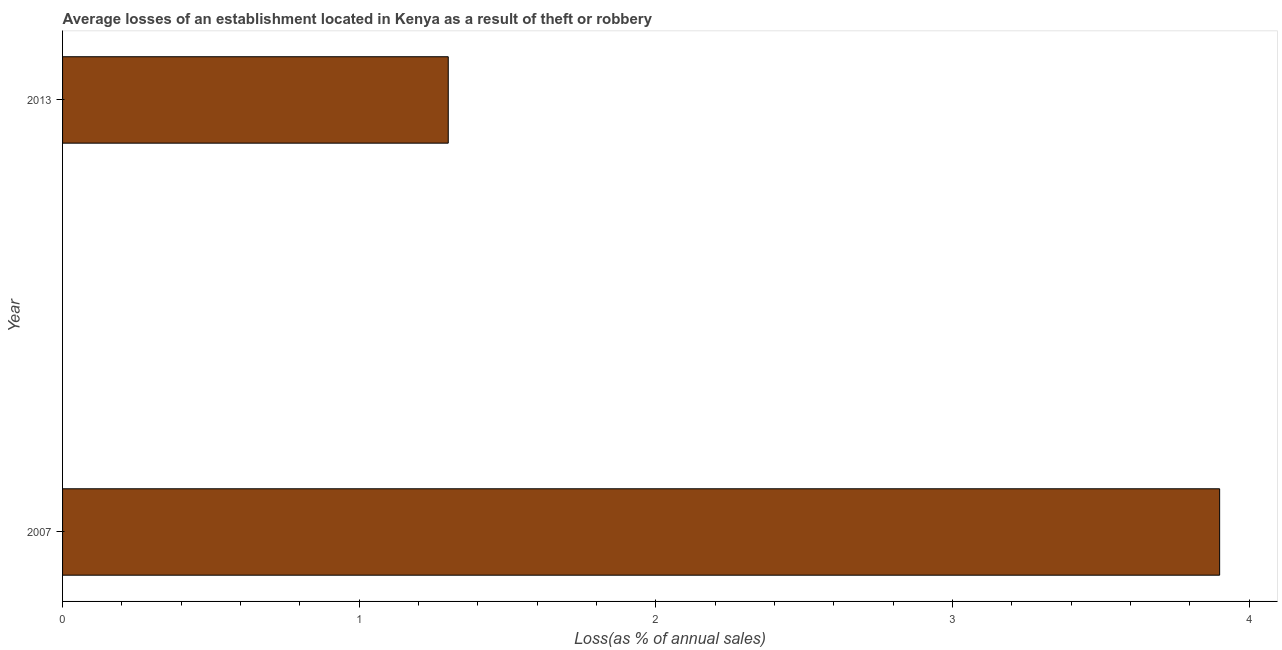Does the graph contain any zero values?
Provide a short and direct response. No. What is the title of the graph?
Make the answer very short. Average losses of an establishment located in Kenya as a result of theft or robbery. What is the label or title of the X-axis?
Offer a very short reply. Loss(as % of annual sales). What is the losses due to theft in 2013?
Your answer should be compact. 1.3. Across all years, what is the maximum losses due to theft?
Offer a terse response. 3.9. In which year was the losses due to theft minimum?
Offer a very short reply. 2013. What is the sum of the losses due to theft?
Your answer should be compact. 5.2. What is the difference between the losses due to theft in 2007 and 2013?
Offer a very short reply. 2.6. What is the average losses due to theft per year?
Give a very brief answer. 2.6. What is the median losses due to theft?
Provide a short and direct response. 2.6. In how many years, is the losses due to theft greater than 0.2 %?
Ensure brevity in your answer.  2. Do a majority of the years between 2007 and 2013 (inclusive) have losses due to theft greater than 2.2 %?
Provide a succinct answer. No. Is the losses due to theft in 2007 less than that in 2013?
Provide a succinct answer. No. Are all the bars in the graph horizontal?
Give a very brief answer. Yes. What is the difference between two consecutive major ticks on the X-axis?
Keep it short and to the point. 1. Are the values on the major ticks of X-axis written in scientific E-notation?
Keep it short and to the point. No. What is the Loss(as % of annual sales) in 2007?
Offer a terse response. 3.9. What is the ratio of the Loss(as % of annual sales) in 2007 to that in 2013?
Offer a very short reply. 3. 